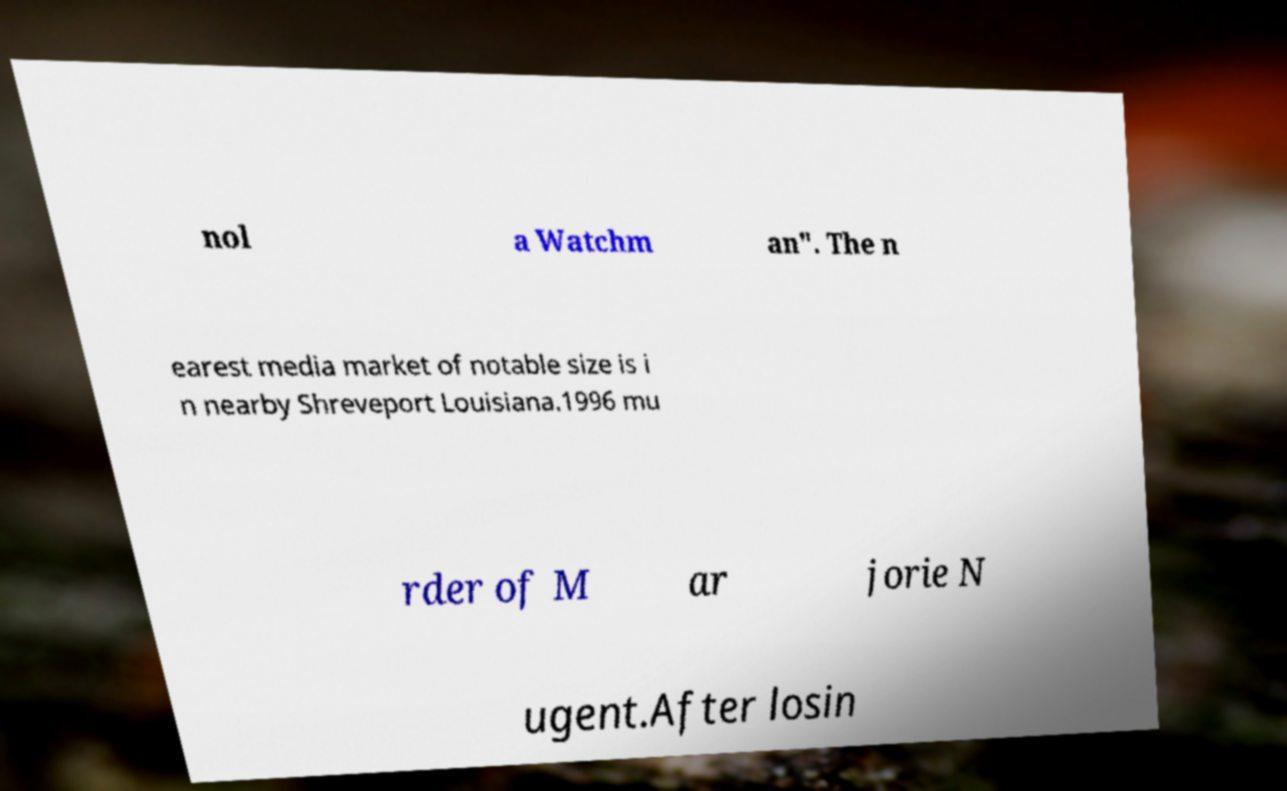I need the written content from this picture converted into text. Can you do that? nol a Watchm an". The n earest media market of notable size is i n nearby Shreveport Louisiana.1996 mu rder of M ar jorie N ugent.After losin 